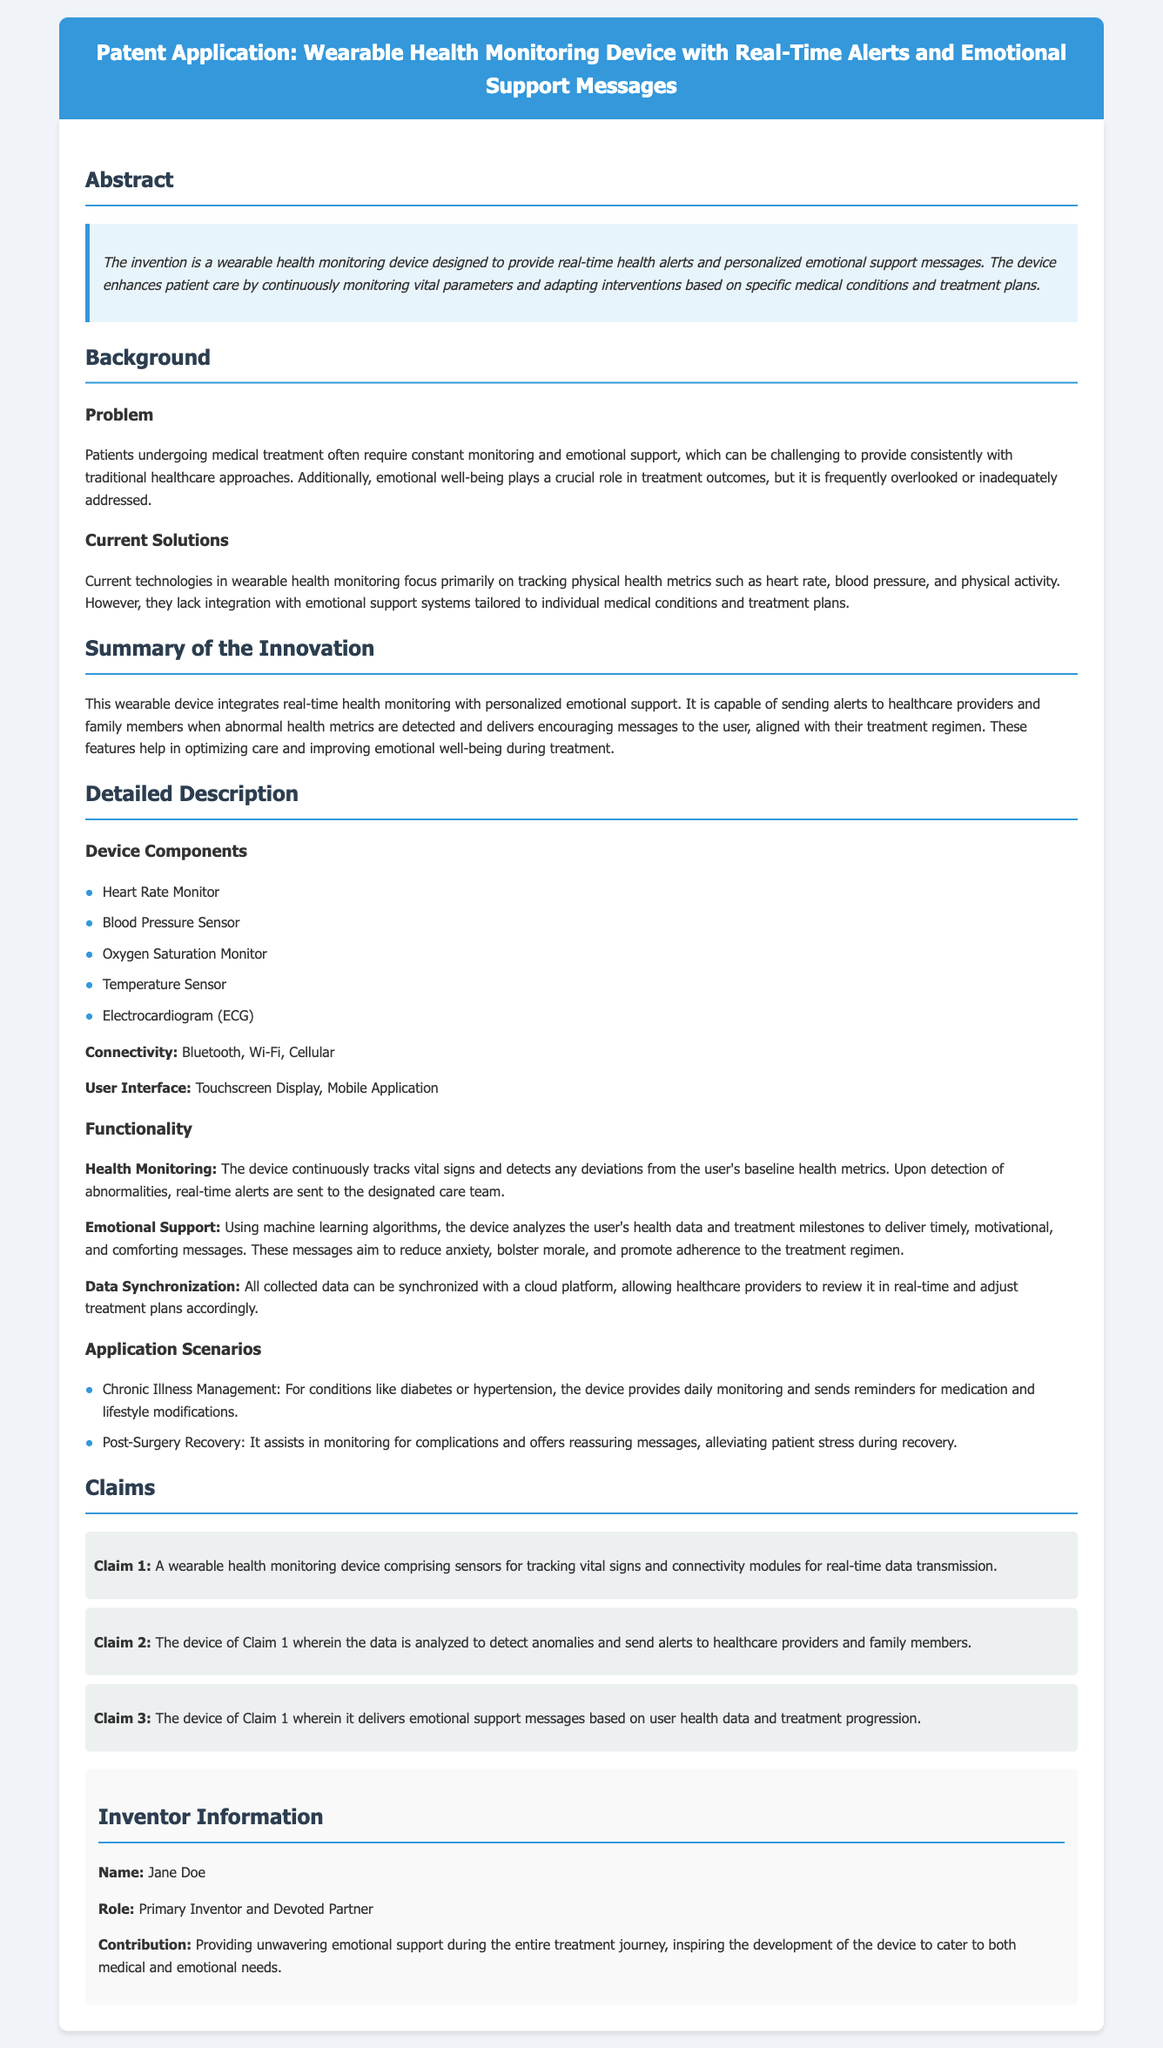What is the title of the patent application? The title is provided in the header of the document.
Answer: Wearable Health Monitoring Device with Real-Time Alerts and Emotional Support Messages Who is the primary inventor? The inventor information section states the name of the primary inventor.
Answer: Jane Doe What type of monitoring does the device provide? The abstract describes the main function of the device related to health monitoring.
Answer: Health monitoring What are the main components of the device? The detailed description lists the components used in the device.
Answer: Heart Rate Monitor, Blood Pressure Sensor, Oxygen Saturation Monitor, Temperature Sensor, Electrocardiogram (ECG) What is the purpose of emotional support messages? The functionality section explains the role of emotional support messages in the user's treatment.
Answer: Reduce anxiety, bolster morale, and promote adherence to the treatment regimen How does the device send alerts? The summary mentions how the device notifies care teams about health metrics.
Answer: Real-time alerts What does Claim 3 relate to? The claims section outlines the features covered in claim 3.
Answer: Emotional support messages based on user health data and treatment progression What application scenario involves diabetes management? The applications section specifies scenarios in which the device can be used.
Answer: Chronic Illness Management What kind of connectivity does the device use? The device’s connectivity options are listed in the detailed description.
Answer: Bluetooth, Wi-Fi, Cellular 